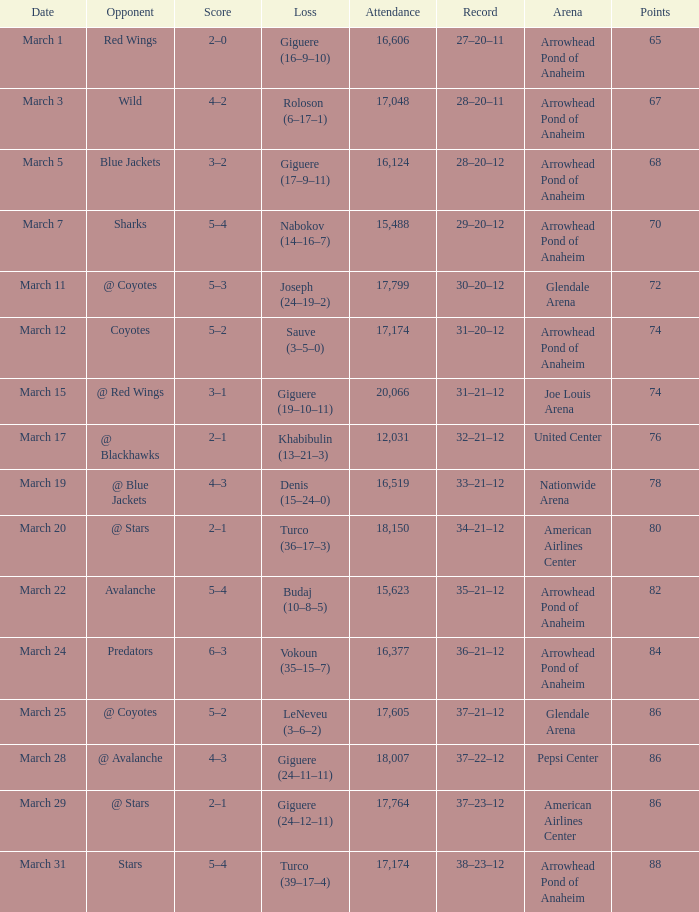What is the presence at joe louis arena? 20066.0. 